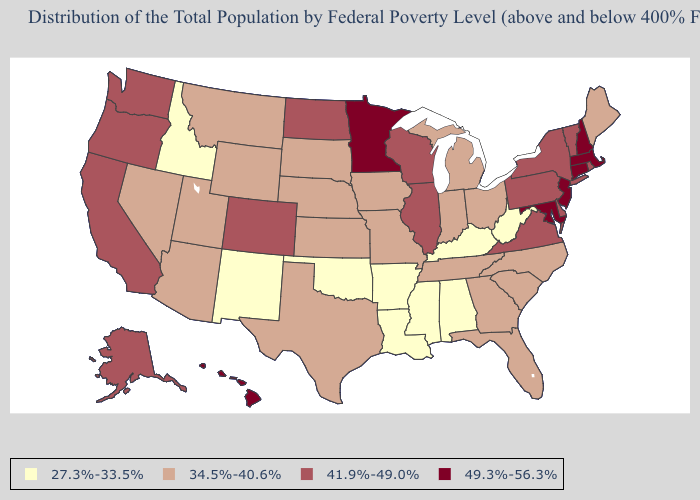Which states have the lowest value in the USA?
Answer briefly. Alabama, Arkansas, Idaho, Kentucky, Louisiana, Mississippi, New Mexico, Oklahoma, West Virginia. What is the lowest value in states that border Utah?
Answer briefly. 27.3%-33.5%. Among the states that border New Hampshire , which have the lowest value?
Short answer required. Maine. What is the value of North Dakota?
Answer briefly. 41.9%-49.0%. Among the states that border Arkansas , does Tennessee have the lowest value?
Be succinct. No. Among the states that border Maryland , which have the highest value?
Be succinct. Delaware, Pennsylvania, Virginia. What is the highest value in states that border Missouri?
Concise answer only. 41.9%-49.0%. Does the first symbol in the legend represent the smallest category?
Concise answer only. Yes. Does Wisconsin have the same value as Pennsylvania?
Write a very short answer. Yes. What is the lowest value in the West?
Write a very short answer. 27.3%-33.5%. How many symbols are there in the legend?
Concise answer only. 4. Does Idaho have the same value as West Virginia?
Concise answer only. Yes. Name the states that have a value in the range 49.3%-56.3%?
Answer briefly. Connecticut, Hawaii, Maryland, Massachusetts, Minnesota, New Hampshire, New Jersey. What is the value of Nevada?
Be succinct. 34.5%-40.6%. Does Minnesota have a lower value than West Virginia?
Quick response, please. No. 